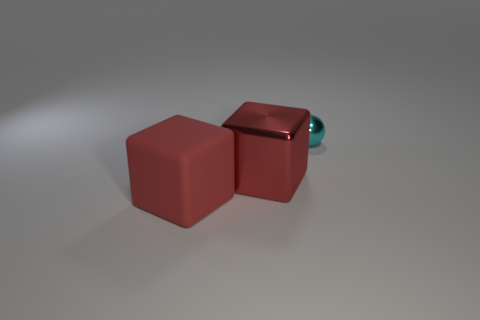What could be the size comparison between the cubes and the sphere? The cubes are significantly larger than the sphere when comparing their dimensions, suggesting that the sphere's diameter could be less than a third of the length of one side of the cubes. Does the size difference indicate anything about how they might be used together? Considering the size difference, if these objects were part of a set, the sphere could serve as a decorative or functional element associated with the cubes, possibly as a knob or a moving part in a larger construct. 